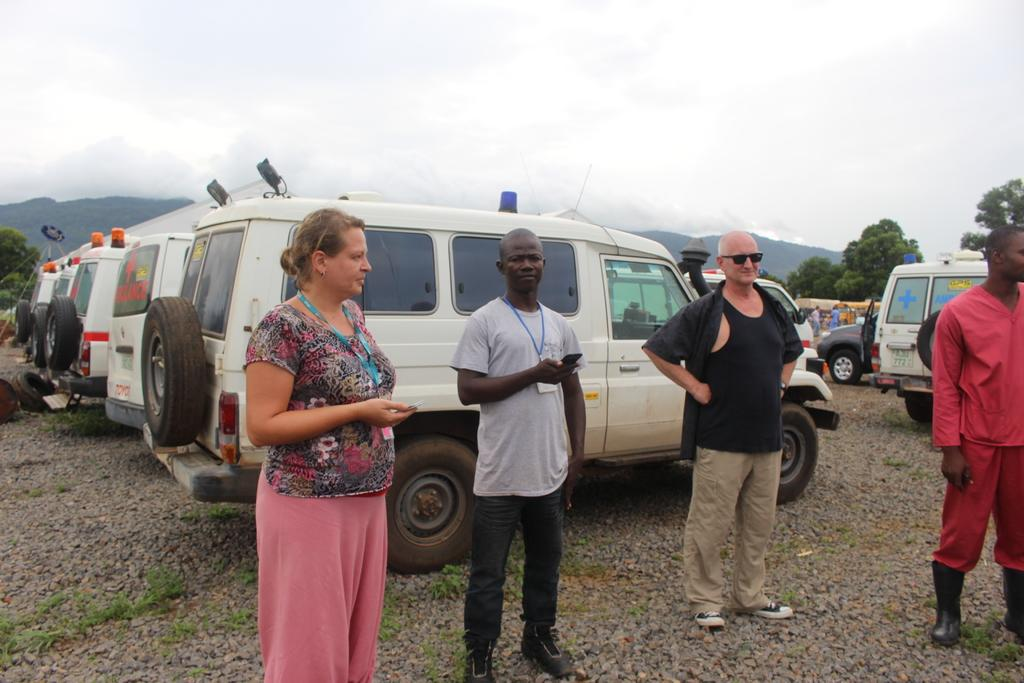How many people are present in the image? There are four people standing in the image. What are the people doing in the image? The people are looking at someone. What can be seen in the background of the image? There are many ambulances on the road in the background of the image. What type of trousers is the person wearing in the image? There is no information about the type of trousers anyone is wearing in the image. --- Facts: 1. There is a person holding a book. 2. The book is titled "The Art of War" by Sun Tzu. 3. The person is sitting on a chair. 4. There is a desk in front of the person. 5. The desk has a lamp and a pen holder. Absurd Topics: elephant, piano, ocean Conversation: What is the person in the image holding? The person in the image is holding a book. What is the title of the book the person is holding? The book is titled "The Art of War" by Sun Tzu. What is the person in the image doing? The person in the image is sitting on a chair. What can be seen on the desk in front of the person? There is a desk in front of the person. The desk has a lamp and a pen holder. Reasoning: Let's think step by step in order to produce the conversation. We start by identifying the main subject in the image, which is the person holding a book. Next, we describe the specific details about the book, such as the title. Then, we observe the actions of the person, noting that they are sitting on a chair. Finally, we describe the objects on the desk in front of the person, which includes a lamp and a pen holder. Absurd Question/Answer: Can you hear the elephant playing the piano in the image? There is no elephant, piano, or ocean present in the image. 